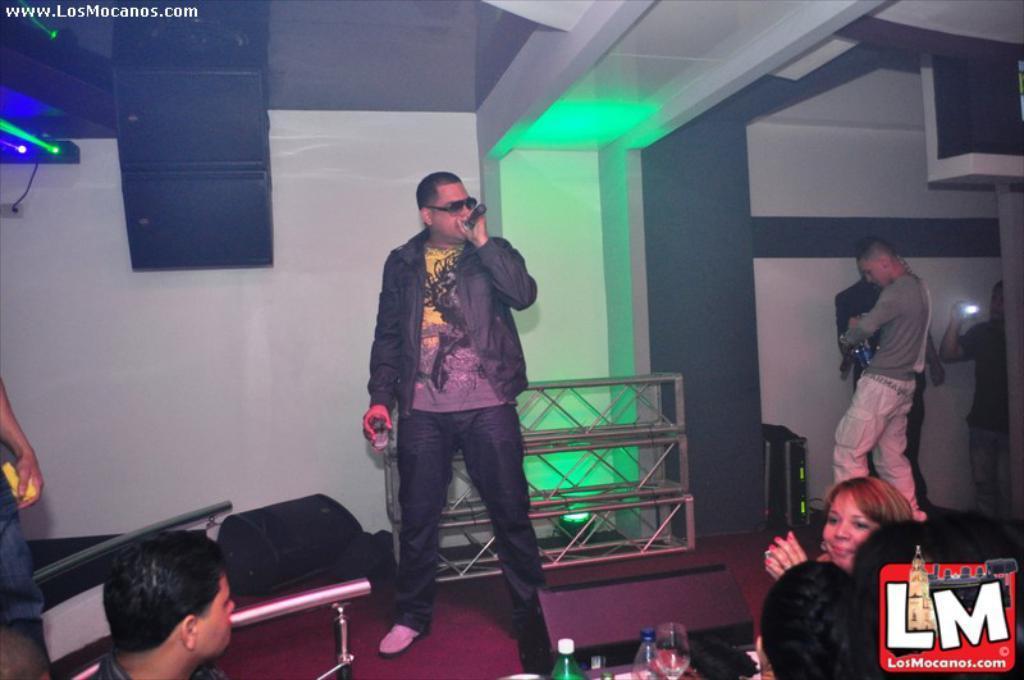Can you describe this image briefly? This picture is clicked inside. In the center there is a person holding an object and a microphone, standing on the ground and seems to be singing. On the left we can see the two persons. On the right we can see the group of persons, metal rods and many other objects. At the top there is a speaker and we can see the roof, focusing lights, wall and some other objects. In the bottom right corner there is a watermark on the image. 